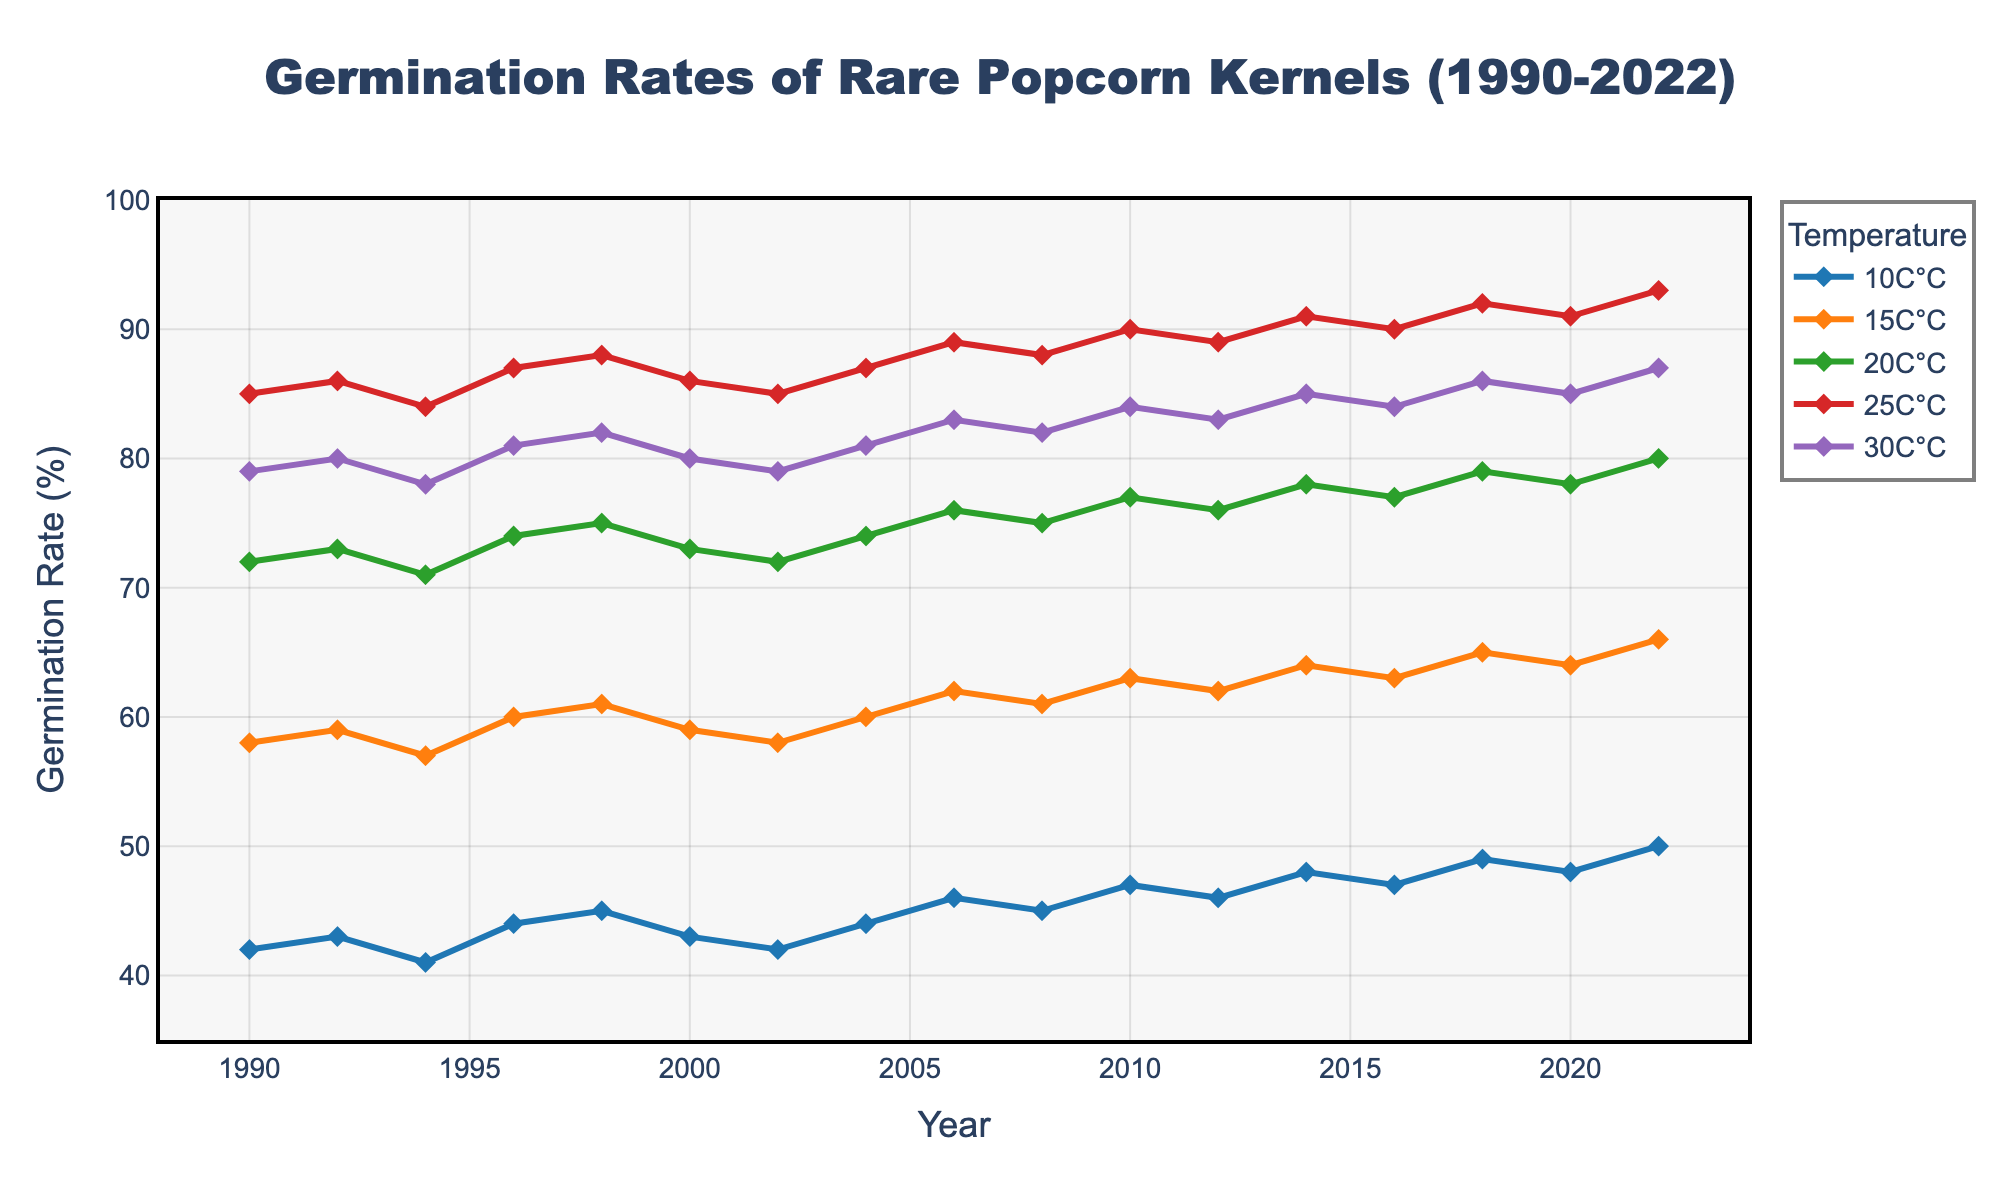What is the overall trend of germination rates at 25°C from 1990 to 2022? To find the trend, look at the values corresponding to 25°C from 1990 to 2022. Notice how the data points increase over the years, showing that the germination rate is generally increasing.
Answer: Increasing Which temperature condition had the highest germination rate in 2022? Compare the germination rates for 2022 across all temperature conditions (10°C, 15°C, 20°C, 25°C, and 30°C). The highest value is 93% under 25°C.
Answer: 25°C What is the difference between the germination rates of 10°C and 30°C in 1990? To find the difference, subtract the germination rate at 10°C (42%) from the germination rate at 30°C (79%) for the year 1990. 79% - 42% = 37%.
Answer: 37% Between which years did the 20°C germination rate reach its maximum? Identify the highest value in the 20°C series and find the corresponding year. The maximum value for 20°C is 80% in the year 2022.
Answer: 2022 How much did the germination rate at 15°C increase from 2000 to 2022? Subtract the germination rate of 15°C in 2000 (59%) from the germination rate in 2022 (66%). 66% - 59% = 7%.
Answer: 7% How do the germination rates at 10°C and 25°C compare from 1990 to 2022? Compare the germination rates for 10°C and 25°C across the years 1990 to 2022. Notice that while both increase, 25°C consistently has higher germination rates than 10°C.
Answer: 25°C > 10°C Which temperature shows the least variation in germination rates from 1990 to 2022? Compare the range of germination rates for all temperatures from 1990 to 2022. Calculate the range for each (max-min) and note that 10°C varies between 41% and 50%. Other temperatures have wider ranges.
Answer: 10°C What is the average germination rate for 30°C from 1990 to 2022? Add all germination rates for 30°C from 1990 to 2022 (79% + 80% + 78% + 81% + 82% + 80% + 79% + 81% + 83% + 82% + 84% + 83% + 85% + 84% + 86% + 85% + 87%) and divide by the number of years (17). Total = 1395, so 1395 / 17 = 82.06%.
Answer: 82.06% Which temperature range shows a consistent increase in germination rates over the period? Observe the germination rates for all temperature ranges and identify that temperatures 20°C, 25°C, and 30°C show a consistent increase from 1990 to 2022.
Answer: 20°C, 25°C, 30°C At which temperature did the germination rate change the most between 2018 and 2022? Calculate the change in germination rates for each temperature between 2018 and 2022. The largest change is at 10°C, which increased from 49% to 50% (1% difference).
Answer: 10°C 